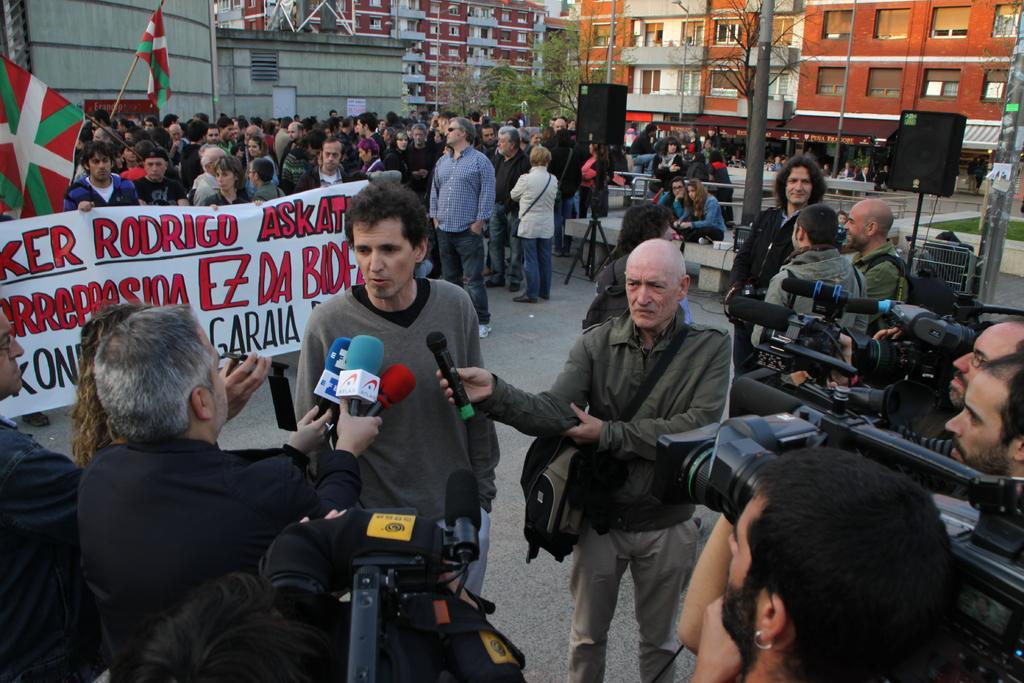How would you summarize this image in a sentence or two? There are groups of people standing. Among them few people are holding the miles and video recorders. This is a banner. I think these are the speakers, which are on the stand. I can see two people sitting. This looks like a pole. These are the two flags, which are hanging to the poles. I can see the buildings with the windows. These are the trees. 